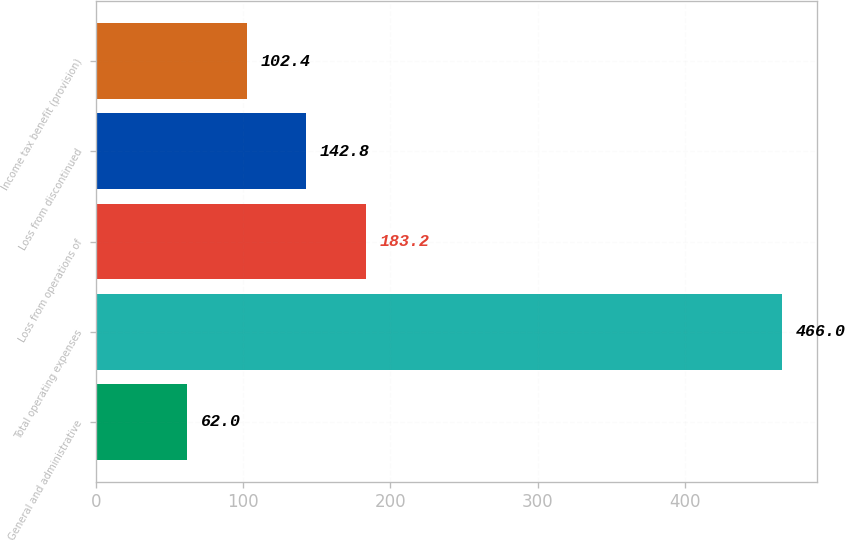Convert chart to OTSL. <chart><loc_0><loc_0><loc_500><loc_500><bar_chart><fcel>General and administrative<fcel>Total operating expenses<fcel>Loss from operations of<fcel>Loss from discontinued<fcel>Income tax benefit (provision)<nl><fcel>62<fcel>466<fcel>183.2<fcel>142.8<fcel>102.4<nl></chart> 